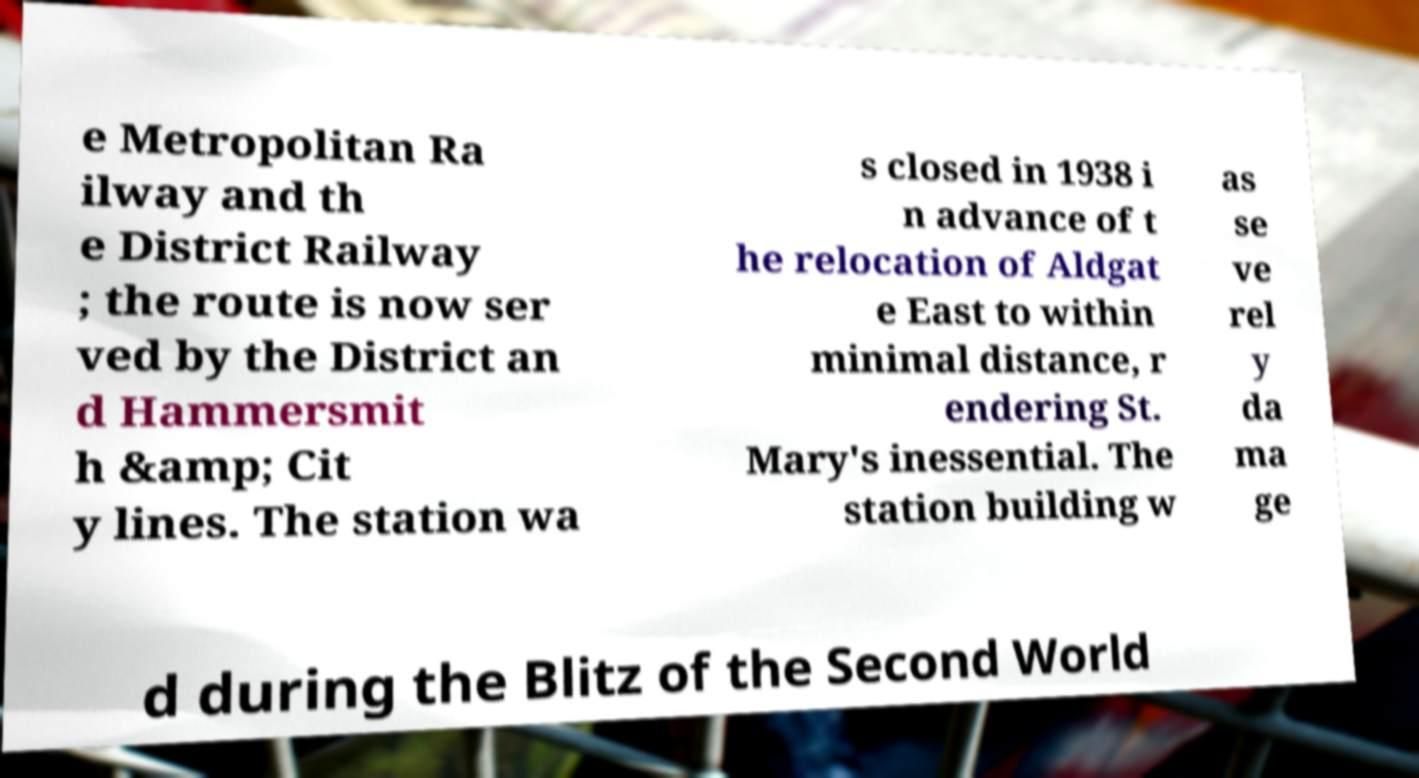For documentation purposes, I need the text within this image transcribed. Could you provide that? e Metropolitan Ra ilway and th e District Railway ; the route is now ser ved by the District an d Hammersmit h &amp; Cit y lines. The station wa s closed in 1938 i n advance of t he relocation of Aldgat e East to within minimal distance, r endering St. Mary's inessential. The station building w as se ve rel y da ma ge d during the Blitz of the Second World 